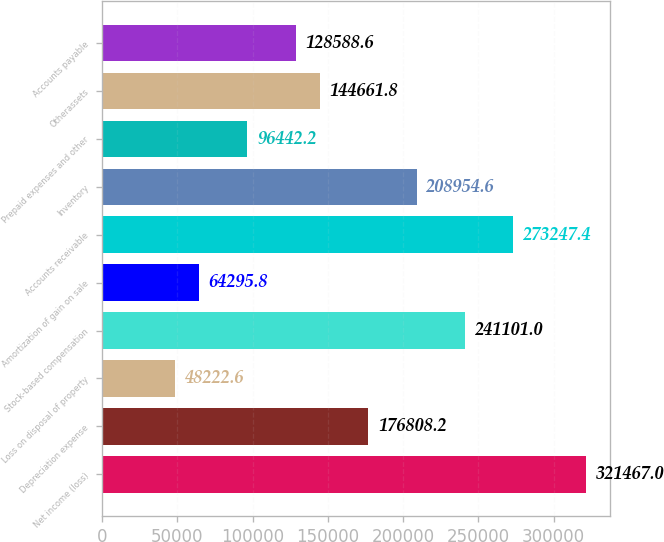Convert chart. <chart><loc_0><loc_0><loc_500><loc_500><bar_chart><fcel>Net income (loss)<fcel>Depreciation expense<fcel>Loss on disposal of property<fcel>Stock-based compensation<fcel>Amortization of gain on sale<fcel>Accounts receivable<fcel>Inventory<fcel>Prepaid expenses and other<fcel>Otherassets<fcel>Accounts payable<nl><fcel>321467<fcel>176808<fcel>48222.6<fcel>241101<fcel>64295.8<fcel>273247<fcel>208955<fcel>96442.2<fcel>144662<fcel>128589<nl></chart> 